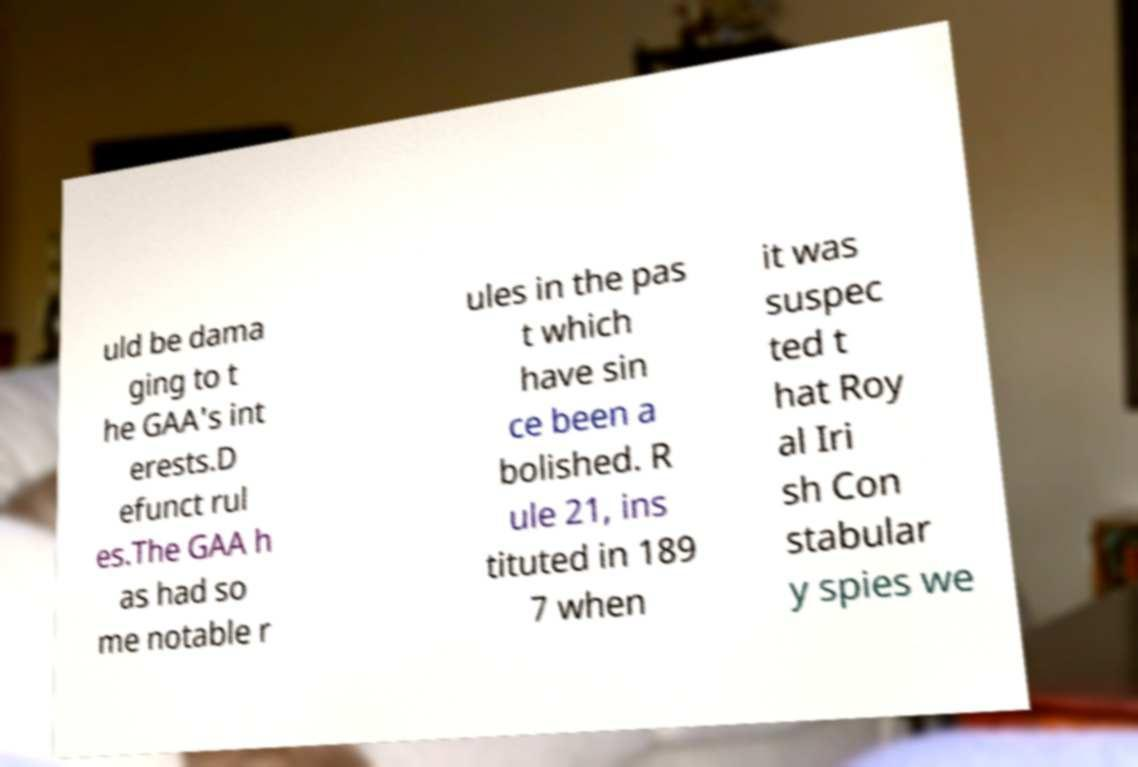Can you read and provide the text displayed in the image?This photo seems to have some interesting text. Can you extract and type it out for me? uld be dama ging to t he GAA's int erests.D efunct rul es.The GAA h as had so me notable r ules in the pas t which have sin ce been a bolished. R ule 21, ins tituted in 189 7 when it was suspec ted t hat Roy al Iri sh Con stabular y spies we 